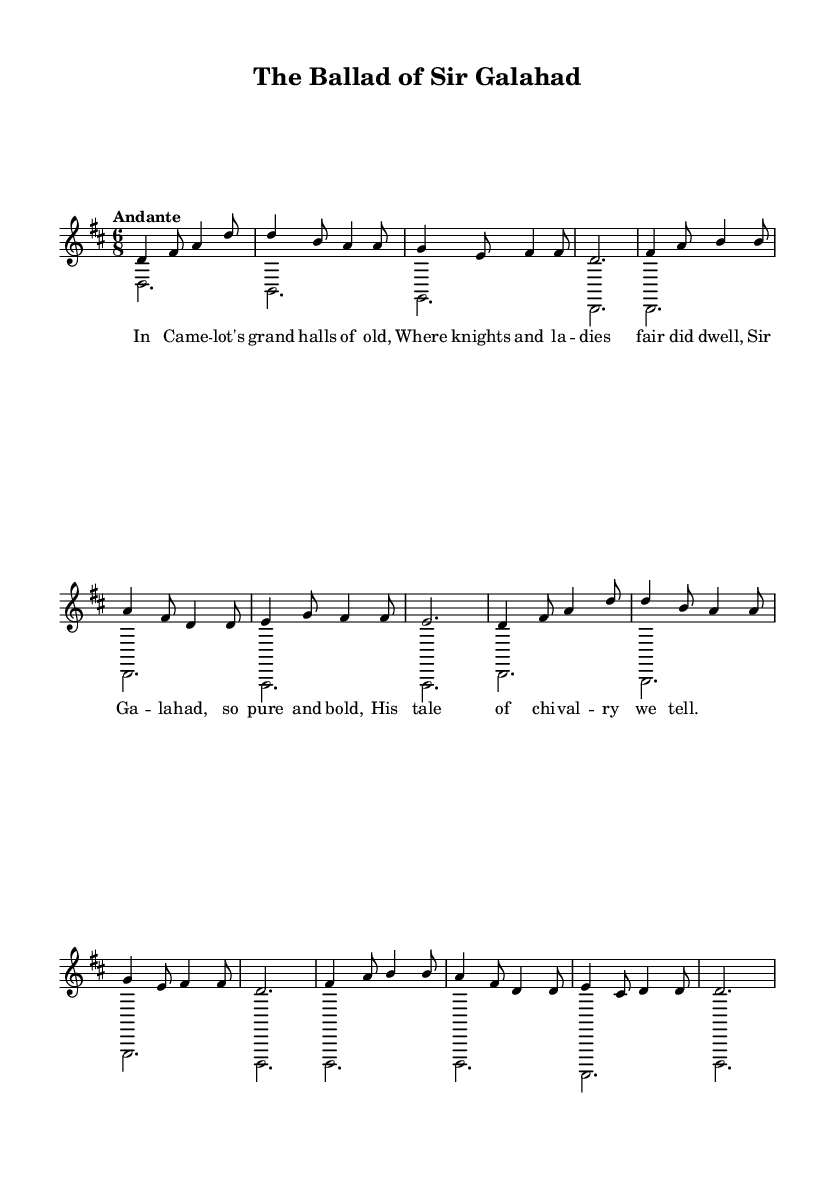What is the key signature of this music? The key signature is indicated at the beginning of the score, which shows two sharps. This corresponds to the key of D major.
Answer: D major What is the time signature of this piece? The time signature is shown at the start of the score, and it reads '6/8', indicating a compound time signature with six eighth notes per measure.
Answer: 6/8 What is the tempo marking for this piece? The tempo marking is located above the staff and states "Andante", which typically means a moderate pace.
Answer: Andante How many measures are in the vocal part of the music? To find the number of measures, we count each segment separated by the bar lines in the vocal part. There are 12 measures.
Answer: 12 What is the highest note in the vocal line? To determine the highest note, we look through the notes in the voice part and identify 'b4' as the highest pitch within the range of the piece.
Answer: b4 What lyrical theme is presented in this troubadour song? The lyrics describe the grandeur of Camelot and the noble character of Sir Galahad, which reflects the themes of chivalry and courtly life typical of troubadour songs.
Answer: Chivalry and courtly life 